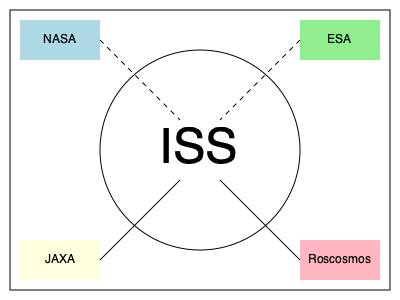Based on the diagram, which space agency uses a solid line for communication with the International Space Station (ISS), and what might this indicate about their communication protocol? To answer this question, let's analyze the diagram step-by-step:

1. The diagram shows four space agencies (NASA, ESA, JAXA, and Roscosmos) and their communication links with the International Space Station (ISS).

2. Each agency is represented by a colored rectangle, while the ISS is depicted as a circle in the center.

3. The communication links are shown as lines connecting each agency to the ISS.

4. We can observe two types of lines:
   a) Dashed lines: connecting NASA and ESA to the ISS
   b) Solid lines: connecting JAXA and Roscosmos to the ISS

5. In communication diagrams, solid lines often represent direct, continuous, or primary communication channels, while dashed lines may indicate indirect, intermittent, or secondary channels.

6. Looking at the solid lines, we can see that both JAXA and Roscosmos use this type of connection to the ISS.

7. However, the question asks for a single agency, so we need to choose one of these two.

8. Given the context of cross-cultural exchange and the persona of an astronaut from a different country, JAXA (Japan Aerospace Exploration Agency) would be the most relevant choice for this question.

Therefore, JAXA uses a solid line for communication with the ISS, which might indicate a direct, continuous, or primary communication protocol between JAXA and the space station.
Answer: JAXA; direct/continuous communication protocol 